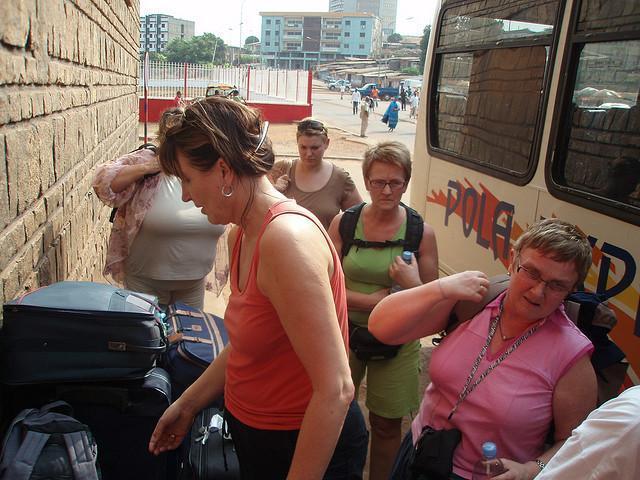How many backpacks are there?
Give a very brief answer. 3. How many suitcases can you see?
Give a very brief answer. 4. How many people can you see?
Give a very brief answer. 6. How many keyboards are shown?
Give a very brief answer. 0. 